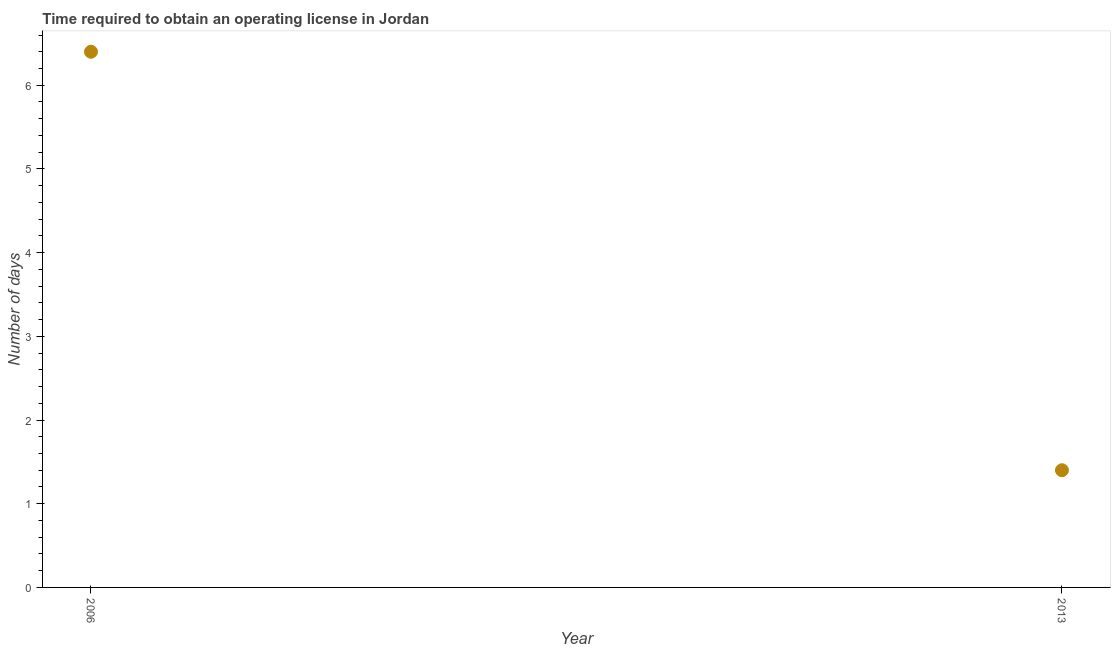In which year was the number of days to obtain operating license maximum?
Your answer should be very brief. 2006. In which year was the number of days to obtain operating license minimum?
Provide a short and direct response. 2013. What is the sum of the number of days to obtain operating license?
Give a very brief answer. 7.8. What is the difference between the number of days to obtain operating license in 2006 and 2013?
Your response must be concise. 5. What is the average number of days to obtain operating license per year?
Ensure brevity in your answer.  3.9. What is the median number of days to obtain operating license?
Offer a very short reply. 3.9. Do a majority of the years between 2006 and 2013 (inclusive) have number of days to obtain operating license greater than 1.4 days?
Keep it short and to the point. No. What is the ratio of the number of days to obtain operating license in 2006 to that in 2013?
Give a very brief answer. 4.57. How many dotlines are there?
Offer a very short reply. 1. How many years are there in the graph?
Your response must be concise. 2. What is the difference between two consecutive major ticks on the Y-axis?
Provide a succinct answer. 1. Does the graph contain any zero values?
Your answer should be compact. No. What is the title of the graph?
Make the answer very short. Time required to obtain an operating license in Jordan. What is the label or title of the Y-axis?
Keep it short and to the point. Number of days. What is the Number of days in 2006?
Make the answer very short. 6.4. What is the difference between the Number of days in 2006 and 2013?
Provide a succinct answer. 5. What is the ratio of the Number of days in 2006 to that in 2013?
Provide a short and direct response. 4.57. 